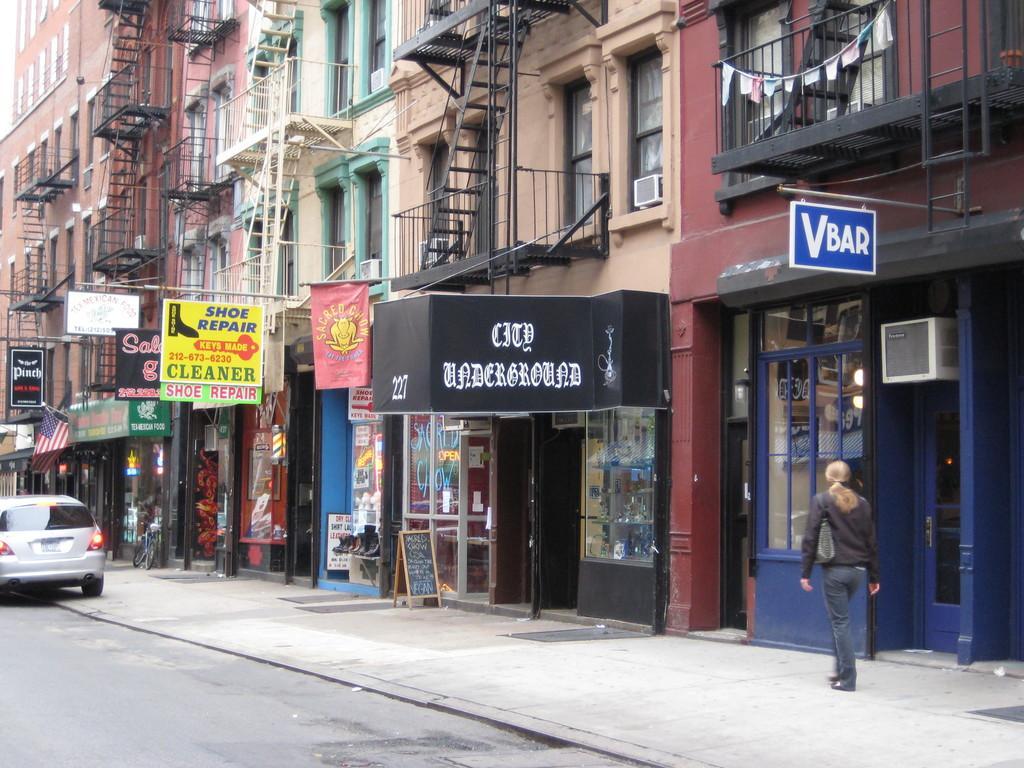Please provide a concise description of this image. In this picture there are buildings and there are boards with some text written on it and there is a person walking and there is a car on the road. 